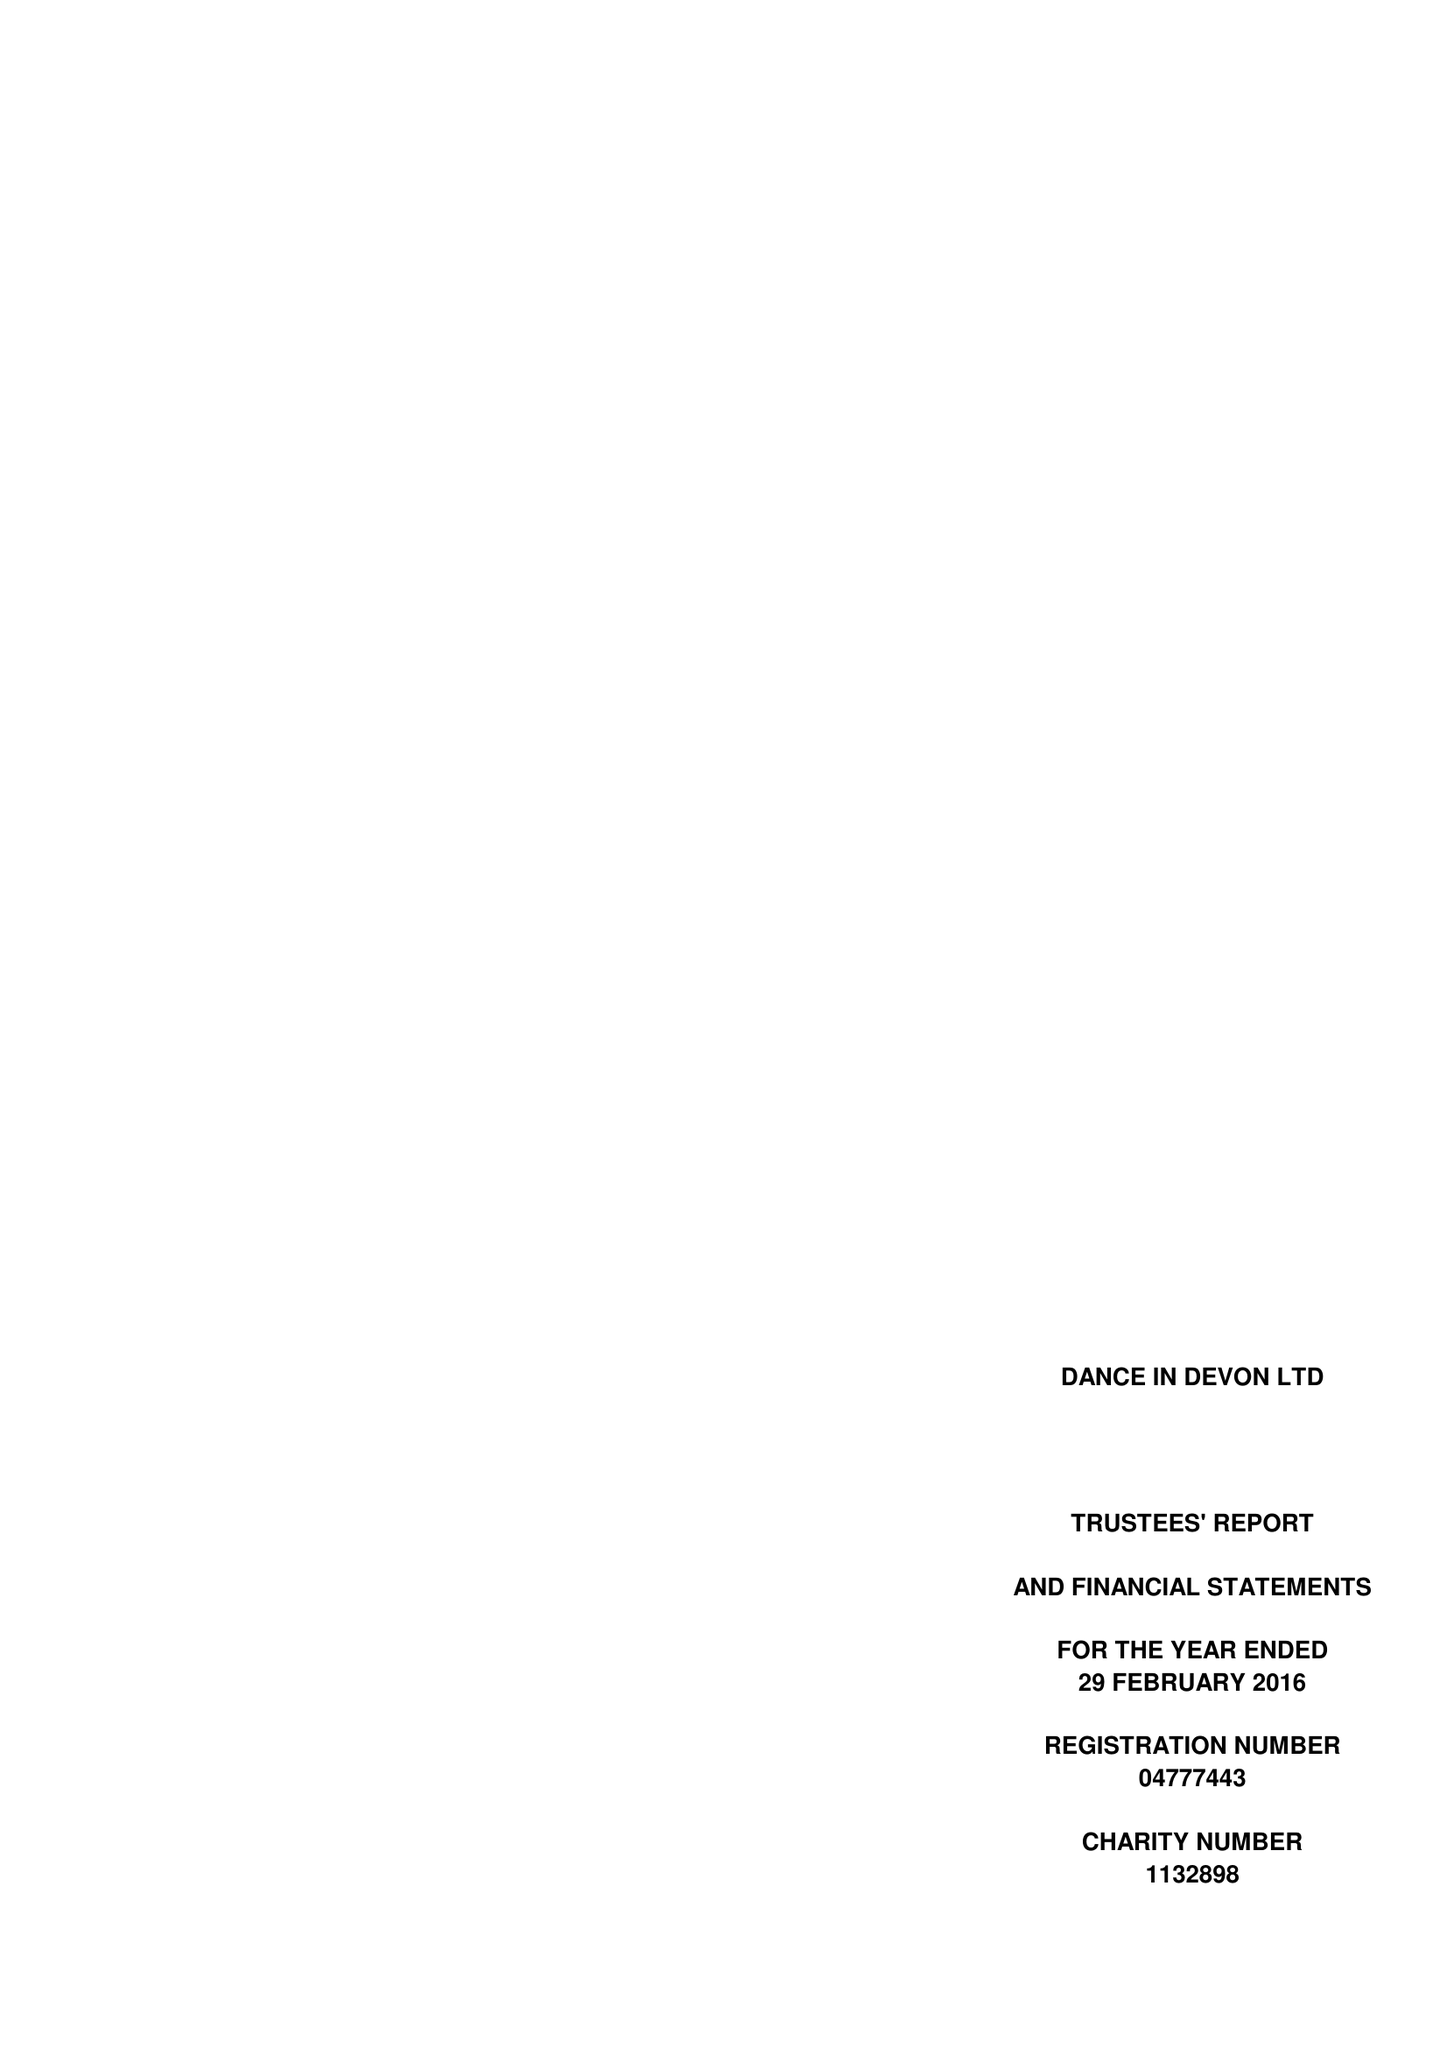What is the value for the report_date?
Answer the question using a single word or phrase. 2016-02-28 